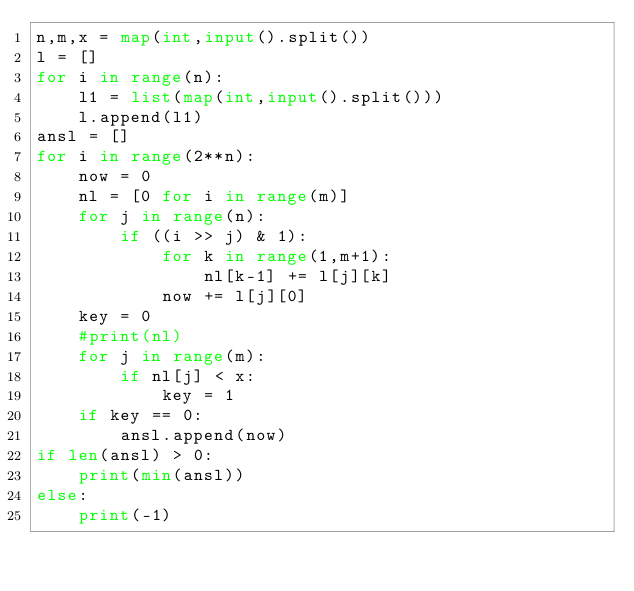<code> <loc_0><loc_0><loc_500><loc_500><_Python_>n,m,x = map(int,input().split())
l = []
for i in range(n):
    l1 = list(map(int,input().split()))
    l.append(l1)
ansl = []
for i in range(2**n):
    now = 0
    nl = [0 for i in range(m)]
    for j in range(n):
        if ((i >> j) & 1):
            for k in range(1,m+1):
                nl[k-1] += l[j][k]
            now += l[j][0]
    key = 0
    #print(nl)
    for j in range(m):
        if nl[j] < x:
            key = 1
    if key == 0:
        ansl.append(now)
if len(ansl) > 0:
    print(min(ansl))
else:
    print(-1)</code> 